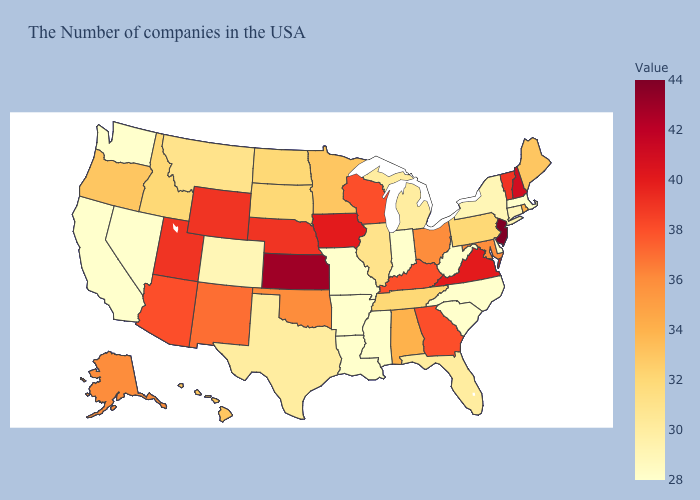Does North Dakota have a higher value than California?
Answer briefly. Yes. Is the legend a continuous bar?
Short answer required. Yes. Does Florida have the lowest value in the USA?
Write a very short answer. No. Among the states that border Georgia , does Alabama have the highest value?
Concise answer only. Yes. Among the states that border Florida , which have the highest value?
Give a very brief answer. Georgia. 